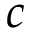Convert formula to latex. <formula><loc_0><loc_0><loc_500><loc_500>c</formula> 